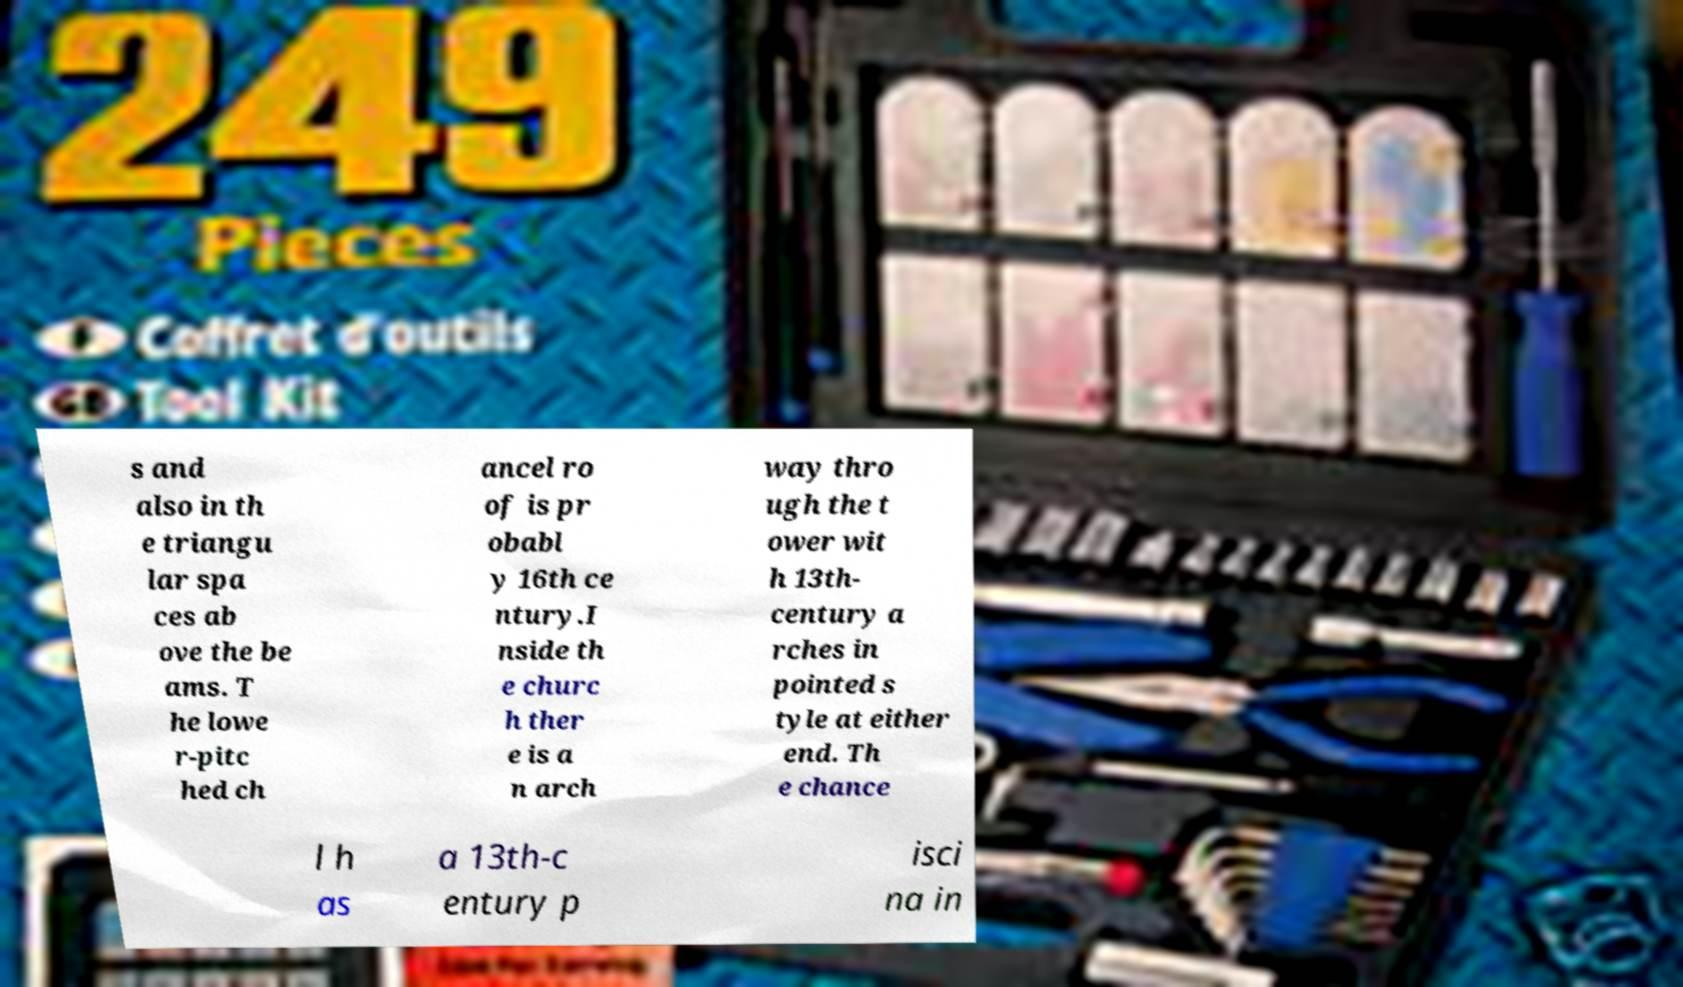There's text embedded in this image that I need extracted. Can you transcribe it verbatim? s and also in th e triangu lar spa ces ab ove the be ams. T he lowe r-pitc hed ch ancel ro of is pr obabl y 16th ce ntury.I nside th e churc h ther e is a n arch way thro ugh the t ower wit h 13th- century a rches in pointed s tyle at either end. Th e chance l h as a 13th-c entury p isci na in 